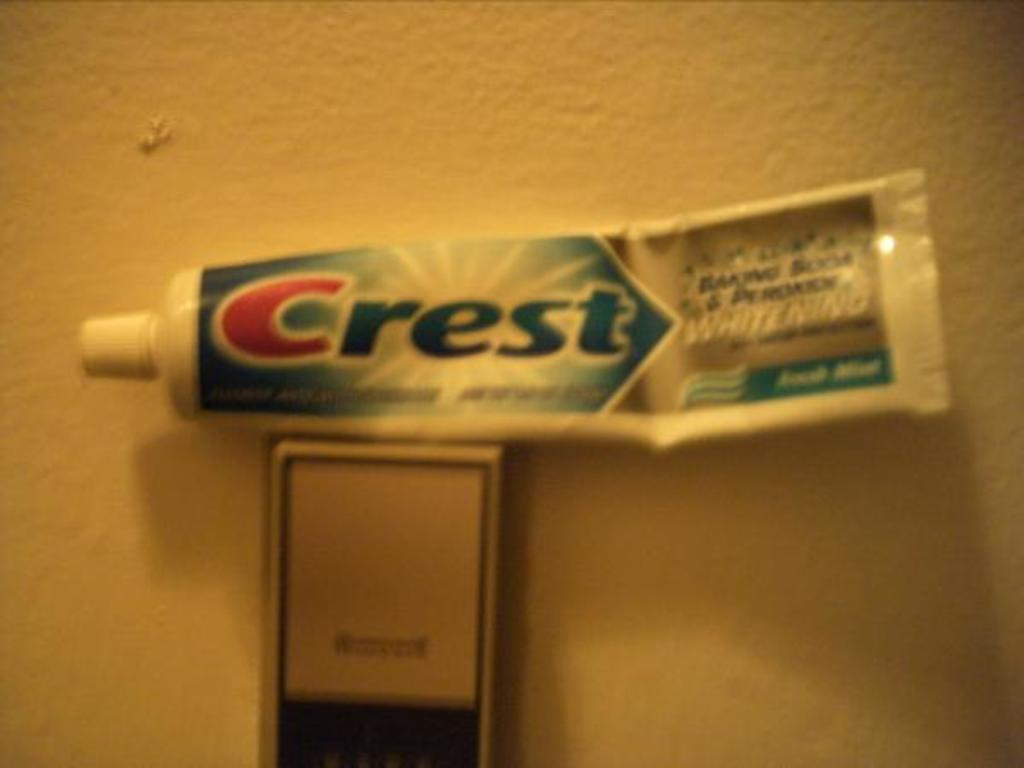<image>
Provide a brief description of the given image. A tube of crest toothpaste on top of a wall fixture. 